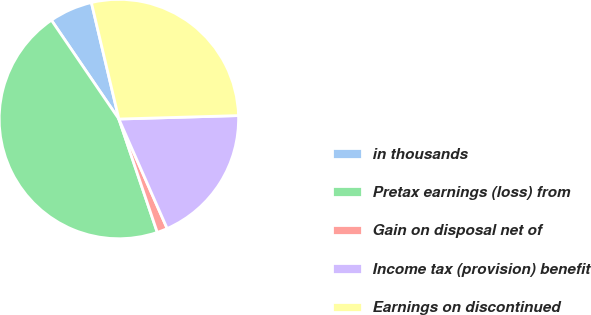Convert chart to OTSL. <chart><loc_0><loc_0><loc_500><loc_500><pie_chart><fcel>in thousands<fcel>Pretax earnings (loss) from<fcel>Gain on disposal net of<fcel>Income tax (provision) benefit<fcel>Earnings on discontinued<nl><fcel>5.84%<fcel>45.67%<fcel>1.41%<fcel>18.85%<fcel>28.23%<nl></chart> 